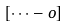Convert formula to latex. <formula><loc_0><loc_0><loc_500><loc_500>\left [ { \cdots - o } \right ]</formula> 